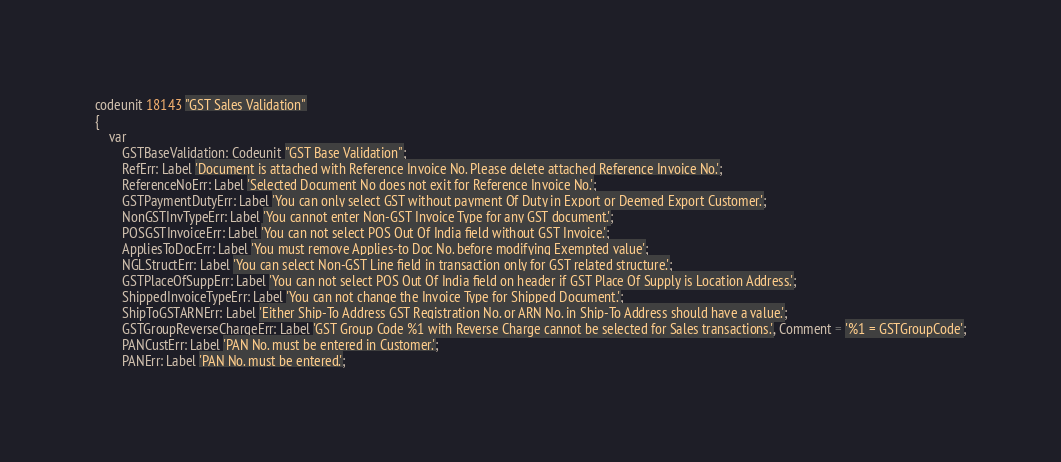Convert code to text. <code><loc_0><loc_0><loc_500><loc_500><_Perl_>codeunit 18143 "GST Sales Validation"
{
    var
        GSTBaseValidation: Codeunit "GST Base Validation";
        RefErr: Label 'Document is attached with Reference Invoice No. Please delete attached Reference Invoice No.';
        ReferenceNoErr: Label 'Selected Document No does not exit for Reference Invoice No.';
        GSTPaymentDutyErr: Label 'You can only select GST without payment Of Duty in Export or Deemed Export Customer.';
        NonGSTInvTypeErr: Label 'You cannot enter Non-GST Invoice Type for any GST document.';
        POSGSTInvoiceErr: Label 'You can not select POS Out Of India field without GST Invoice.';
        AppliesToDocErr: Label 'You must remove Applies-to Doc No. before modifying Exempted value';
        NGLStructErr: Label 'You can select Non-GST Line field in transaction only for GST related structure.';
        GSTPlaceOfSuppErr: Label 'You can not select POS Out Of India field on header if GST Place Of Supply is Location Address.';
        ShippedInvoiceTypeErr: Label 'You can not change the Invoice Type for Shipped Document.';
        ShipToGSTARNErr: Label 'Either Ship-To Address GST Registration No. or ARN No. in Ship-To Address should have a value.';
        GSTGroupReverseChargeErr: Label 'GST Group Code %1 with Reverse Charge cannot be selected for Sales transactions.', Comment = '%1 = GSTGroupCode';
        PANCustErr: Label 'PAN No. must be entered in Customer.';
        PANErr: Label 'PAN No. must be entered.';</code> 